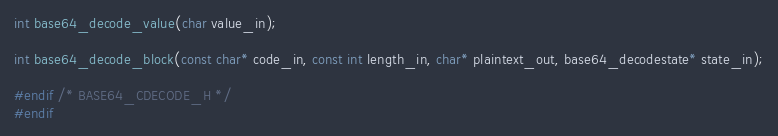<code> <loc_0><loc_0><loc_500><loc_500><_C_>
int base64_decode_value(char value_in);

int base64_decode_block(const char* code_in, const int length_in, char* plaintext_out, base64_decodestate* state_in);

#endif /* BASE64_CDECODE_H */
#endif
</code> 